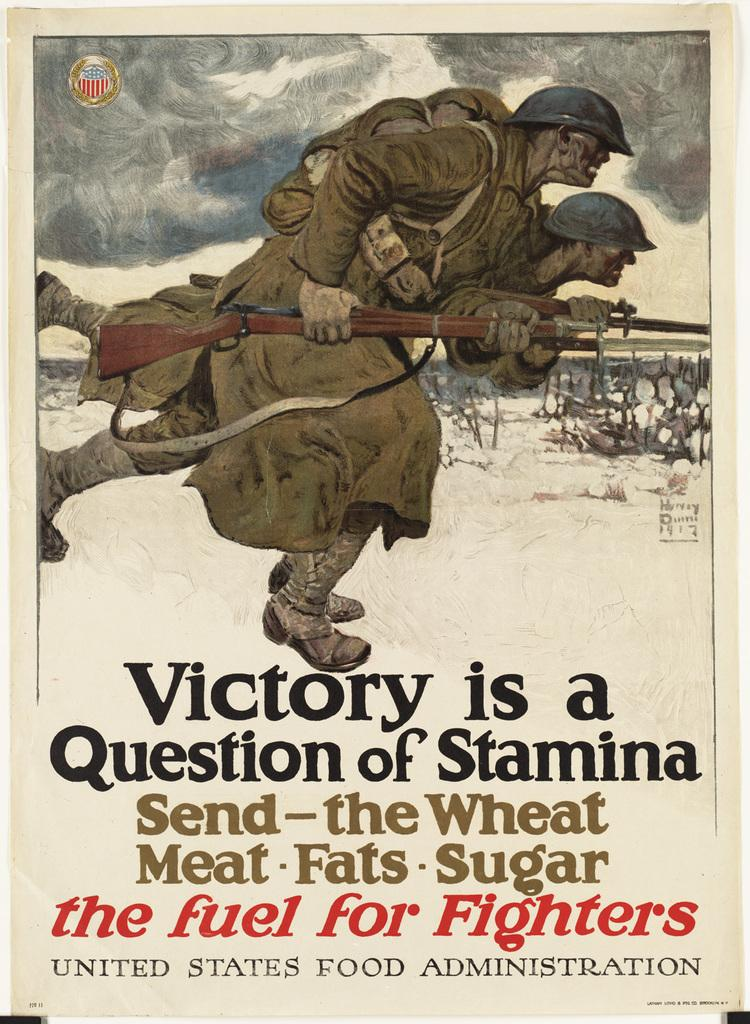How many people are in the image? There are two persons in the image. What are the persons holding in the image? The persons are holding guns. Can you describe any other objects or features in the image? There is a poster with text in the image. What type of drug can be seen in the image? There is no drug present in the image. What kind of list is visible on the poster in the image? The poster in the image does not contain a list; it only has text. 